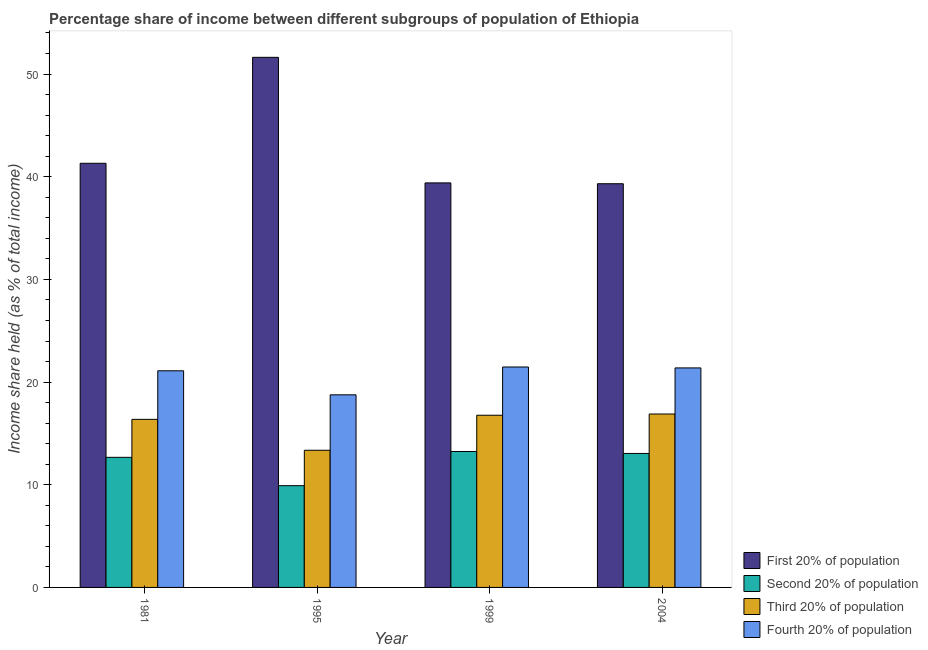How many different coloured bars are there?
Your answer should be very brief. 4. Are the number of bars per tick equal to the number of legend labels?
Your answer should be very brief. Yes. How many bars are there on the 3rd tick from the left?
Make the answer very short. 4. In how many cases, is the number of bars for a given year not equal to the number of legend labels?
Keep it short and to the point. 0. What is the share of the income held by fourth 20% of the population in 1995?
Give a very brief answer. 18.76. Across all years, what is the maximum share of the income held by fourth 20% of the population?
Provide a short and direct response. 21.47. Across all years, what is the minimum share of the income held by first 20% of the population?
Ensure brevity in your answer.  39.32. In which year was the share of the income held by first 20% of the population maximum?
Give a very brief answer. 1995. What is the total share of the income held by fourth 20% of the population in the graph?
Make the answer very short. 82.71. What is the difference between the share of the income held by third 20% of the population in 1981 and that in 2004?
Your answer should be very brief. -0.52. What is the difference between the share of the income held by fourth 20% of the population in 2004 and the share of the income held by third 20% of the population in 1981?
Provide a short and direct response. 0.28. What is the average share of the income held by second 20% of the population per year?
Provide a succinct answer. 12.22. In the year 2004, what is the difference between the share of the income held by second 20% of the population and share of the income held by fourth 20% of the population?
Your answer should be compact. 0. What is the ratio of the share of the income held by fourth 20% of the population in 1981 to that in 1999?
Your answer should be compact. 0.98. Is the share of the income held by second 20% of the population in 1999 less than that in 2004?
Your response must be concise. No. Is the difference between the share of the income held by second 20% of the population in 1981 and 1995 greater than the difference between the share of the income held by fourth 20% of the population in 1981 and 1995?
Provide a succinct answer. No. What is the difference between the highest and the second highest share of the income held by first 20% of the population?
Your response must be concise. 10.32. What is the difference between the highest and the lowest share of the income held by third 20% of the population?
Provide a succinct answer. 3.53. In how many years, is the share of the income held by first 20% of the population greater than the average share of the income held by first 20% of the population taken over all years?
Ensure brevity in your answer.  1. Is the sum of the share of the income held by first 20% of the population in 1981 and 1999 greater than the maximum share of the income held by third 20% of the population across all years?
Your response must be concise. Yes. Is it the case that in every year, the sum of the share of the income held by third 20% of the population and share of the income held by fourth 20% of the population is greater than the sum of share of the income held by second 20% of the population and share of the income held by first 20% of the population?
Keep it short and to the point. Yes. What does the 3rd bar from the left in 1999 represents?
Offer a very short reply. Third 20% of population. What does the 2nd bar from the right in 1981 represents?
Your answer should be compact. Third 20% of population. Is it the case that in every year, the sum of the share of the income held by first 20% of the population and share of the income held by second 20% of the population is greater than the share of the income held by third 20% of the population?
Offer a terse response. Yes. Are all the bars in the graph horizontal?
Give a very brief answer. No. Are the values on the major ticks of Y-axis written in scientific E-notation?
Your answer should be compact. No. Does the graph contain any zero values?
Your answer should be very brief. No. Where does the legend appear in the graph?
Ensure brevity in your answer.  Bottom right. How are the legend labels stacked?
Offer a terse response. Vertical. What is the title of the graph?
Your answer should be very brief. Percentage share of income between different subgroups of population of Ethiopia. What is the label or title of the Y-axis?
Provide a short and direct response. Income share held (as % of total income). What is the Income share held (as % of total income) of First 20% of population in 1981?
Provide a succinct answer. 41.31. What is the Income share held (as % of total income) in Second 20% of population in 1981?
Give a very brief answer. 12.67. What is the Income share held (as % of total income) in Third 20% of population in 1981?
Your answer should be compact. 16.37. What is the Income share held (as % of total income) of Fourth 20% of population in 1981?
Provide a short and direct response. 21.1. What is the Income share held (as % of total income) in First 20% of population in 1995?
Offer a terse response. 51.63. What is the Income share held (as % of total income) of Second 20% of population in 1995?
Provide a short and direct response. 9.91. What is the Income share held (as % of total income) of Third 20% of population in 1995?
Make the answer very short. 13.36. What is the Income share held (as % of total income) of Fourth 20% of population in 1995?
Offer a terse response. 18.76. What is the Income share held (as % of total income) of First 20% of population in 1999?
Ensure brevity in your answer.  39.4. What is the Income share held (as % of total income) of Second 20% of population in 1999?
Offer a very short reply. 13.24. What is the Income share held (as % of total income) of Third 20% of population in 1999?
Offer a terse response. 16.77. What is the Income share held (as % of total income) in Fourth 20% of population in 1999?
Ensure brevity in your answer.  21.47. What is the Income share held (as % of total income) in First 20% of population in 2004?
Your response must be concise. 39.32. What is the Income share held (as % of total income) of Second 20% of population in 2004?
Offer a very short reply. 13.05. What is the Income share held (as % of total income) in Third 20% of population in 2004?
Ensure brevity in your answer.  16.89. What is the Income share held (as % of total income) of Fourth 20% of population in 2004?
Your response must be concise. 21.38. Across all years, what is the maximum Income share held (as % of total income) in First 20% of population?
Provide a succinct answer. 51.63. Across all years, what is the maximum Income share held (as % of total income) of Second 20% of population?
Provide a succinct answer. 13.24. Across all years, what is the maximum Income share held (as % of total income) of Third 20% of population?
Keep it short and to the point. 16.89. Across all years, what is the maximum Income share held (as % of total income) in Fourth 20% of population?
Provide a short and direct response. 21.47. Across all years, what is the minimum Income share held (as % of total income) of First 20% of population?
Provide a succinct answer. 39.32. Across all years, what is the minimum Income share held (as % of total income) in Second 20% of population?
Your answer should be very brief. 9.91. Across all years, what is the minimum Income share held (as % of total income) in Third 20% of population?
Your response must be concise. 13.36. Across all years, what is the minimum Income share held (as % of total income) in Fourth 20% of population?
Your answer should be very brief. 18.76. What is the total Income share held (as % of total income) of First 20% of population in the graph?
Your answer should be very brief. 171.66. What is the total Income share held (as % of total income) in Second 20% of population in the graph?
Offer a very short reply. 48.87. What is the total Income share held (as % of total income) in Third 20% of population in the graph?
Keep it short and to the point. 63.39. What is the total Income share held (as % of total income) of Fourth 20% of population in the graph?
Your answer should be compact. 82.71. What is the difference between the Income share held (as % of total income) of First 20% of population in 1981 and that in 1995?
Keep it short and to the point. -10.32. What is the difference between the Income share held (as % of total income) of Second 20% of population in 1981 and that in 1995?
Make the answer very short. 2.76. What is the difference between the Income share held (as % of total income) in Third 20% of population in 1981 and that in 1995?
Provide a succinct answer. 3.01. What is the difference between the Income share held (as % of total income) of Fourth 20% of population in 1981 and that in 1995?
Ensure brevity in your answer.  2.34. What is the difference between the Income share held (as % of total income) in First 20% of population in 1981 and that in 1999?
Ensure brevity in your answer.  1.91. What is the difference between the Income share held (as % of total income) of Second 20% of population in 1981 and that in 1999?
Provide a succinct answer. -0.57. What is the difference between the Income share held (as % of total income) in Fourth 20% of population in 1981 and that in 1999?
Your response must be concise. -0.37. What is the difference between the Income share held (as % of total income) in First 20% of population in 1981 and that in 2004?
Offer a very short reply. 1.99. What is the difference between the Income share held (as % of total income) of Second 20% of population in 1981 and that in 2004?
Your response must be concise. -0.38. What is the difference between the Income share held (as % of total income) of Third 20% of population in 1981 and that in 2004?
Offer a terse response. -0.52. What is the difference between the Income share held (as % of total income) in Fourth 20% of population in 1981 and that in 2004?
Provide a succinct answer. -0.28. What is the difference between the Income share held (as % of total income) in First 20% of population in 1995 and that in 1999?
Give a very brief answer. 12.23. What is the difference between the Income share held (as % of total income) of Second 20% of population in 1995 and that in 1999?
Provide a short and direct response. -3.33. What is the difference between the Income share held (as % of total income) of Third 20% of population in 1995 and that in 1999?
Your answer should be compact. -3.41. What is the difference between the Income share held (as % of total income) in Fourth 20% of population in 1995 and that in 1999?
Give a very brief answer. -2.71. What is the difference between the Income share held (as % of total income) of First 20% of population in 1995 and that in 2004?
Offer a terse response. 12.31. What is the difference between the Income share held (as % of total income) of Second 20% of population in 1995 and that in 2004?
Provide a short and direct response. -3.14. What is the difference between the Income share held (as % of total income) of Third 20% of population in 1995 and that in 2004?
Offer a terse response. -3.53. What is the difference between the Income share held (as % of total income) in Fourth 20% of population in 1995 and that in 2004?
Provide a succinct answer. -2.62. What is the difference between the Income share held (as % of total income) in First 20% of population in 1999 and that in 2004?
Provide a short and direct response. 0.08. What is the difference between the Income share held (as % of total income) of Second 20% of population in 1999 and that in 2004?
Make the answer very short. 0.19. What is the difference between the Income share held (as % of total income) in Third 20% of population in 1999 and that in 2004?
Offer a very short reply. -0.12. What is the difference between the Income share held (as % of total income) of Fourth 20% of population in 1999 and that in 2004?
Make the answer very short. 0.09. What is the difference between the Income share held (as % of total income) in First 20% of population in 1981 and the Income share held (as % of total income) in Second 20% of population in 1995?
Your answer should be compact. 31.4. What is the difference between the Income share held (as % of total income) of First 20% of population in 1981 and the Income share held (as % of total income) of Third 20% of population in 1995?
Your answer should be compact. 27.95. What is the difference between the Income share held (as % of total income) of First 20% of population in 1981 and the Income share held (as % of total income) of Fourth 20% of population in 1995?
Give a very brief answer. 22.55. What is the difference between the Income share held (as % of total income) in Second 20% of population in 1981 and the Income share held (as % of total income) in Third 20% of population in 1995?
Offer a very short reply. -0.69. What is the difference between the Income share held (as % of total income) in Second 20% of population in 1981 and the Income share held (as % of total income) in Fourth 20% of population in 1995?
Your answer should be very brief. -6.09. What is the difference between the Income share held (as % of total income) in Third 20% of population in 1981 and the Income share held (as % of total income) in Fourth 20% of population in 1995?
Ensure brevity in your answer.  -2.39. What is the difference between the Income share held (as % of total income) of First 20% of population in 1981 and the Income share held (as % of total income) of Second 20% of population in 1999?
Your answer should be very brief. 28.07. What is the difference between the Income share held (as % of total income) of First 20% of population in 1981 and the Income share held (as % of total income) of Third 20% of population in 1999?
Your response must be concise. 24.54. What is the difference between the Income share held (as % of total income) of First 20% of population in 1981 and the Income share held (as % of total income) of Fourth 20% of population in 1999?
Provide a short and direct response. 19.84. What is the difference between the Income share held (as % of total income) in Second 20% of population in 1981 and the Income share held (as % of total income) in Fourth 20% of population in 1999?
Make the answer very short. -8.8. What is the difference between the Income share held (as % of total income) in First 20% of population in 1981 and the Income share held (as % of total income) in Second 20% of population in 2004?
Give a very brief answer. 28.26. What is the difference between the Income share held (as % of total income) in First 20% of population in 1981 and the Income share held (as % of total income) in Third 20% of population in 2004?
Make the answer very short. 24.42. What is the difference between the Income share held (as % of total income) of First 20% of population in 1981 and the Income share held (as % of total income) of Fourth 20% of population in 2004?
Your answer should be compact. 19.93. What is the difference between the Income share held (as % of total income) of Second 20% of population in 1981 and the Income share held (as % of total income) of Third 20% of population in 2004?
Provide a succinct answer. -4.22. What is the difference between the Income share held (as % of total income) in Second 20% of population in 1981 and the Income share held (as % of total income) in Fourth 20% of population in 2004?
Your response must be concise. -8.71. What is the difference between the Income share held (as % of total income) in Third 20% of population in 1981 and the Income share held (as % of total income) in Fourth 20% of population in 2004?
Give a very brief answer. -5.01. What is the difference between the Income share held (as % of total income) of First 20% of population in 1995 and the Income share held (as % of total income) of Second 20% of population in 1999?
Your response must be concise. 38.39. What is the difference between the Income share held (as % of total income) of First 20% of population in 1995 and the Income share held (as % of total income) of Third 20% of population in 1999?
Ensure brevity in your answer.  34.86. What is the difference between the Income share held (as % of total income) in First 20% of population in 1995 and the Income share held (as % of total income) in Fourth 20% of population in 1999?
Provide a succinct answer. 30.16. What is the difference between the Income share held (as % of total income) in Second 20% of population in 1995 and the Income share held (as % of total income) in Third 20% of population in 1999?
Give a very brief answer. -6.86. What is the difference between the Income share held (as % of total income) in Second 20% of population in 1995 and the Income share held (as % of total income) in Fourth 20% of population in 1999?
Give a very brief answer. -11.56. What is the difference between the Income share held (as % of total income) of Third 20% of population in 1995 and the Income share held (as % of total income) of Fourth 20% of population in 1999?
Provide a succinct answer. -8.11. What is the difference between the Income share held (as % of total income) of First 20% of population in 1995 and the Income share held (as % of total income) of Second 20% of population in 2004?
Give a very brief answer. 38.58. What is the difference between the Income share held (as % of total income) in First 20% of population in 1995 and the Income share held (as % of total income) in Third 20% of population in 2004?
Offer a very short reply. 34.74. What is the difference between the Income share held (as % of total income) of First 20% of population in 1995 and the Income share held (as % of total income) of Fourth 20% of population in 2004?
Make the answer very short. 30.25. What is the difference between the Income share held (as % of total income) in Second 20% of population in 1995 and the Income share held (as % of total income) in Third 20% of population in 2004?
Provide a succinct answer. -6.98. What is the difference between the Income share held (as % of total income) of Second 20% of population in 1995 and the Income share held (as % of total income) of Fourth 20% of population in 2004?
Your answer should be very brief. -11.47. What is the difference between the Income share held (as % of total income) in Third 20% of population in 1995 and the Income share held (as % of total income) in Fourth 20% of population in 2004?
Your answer should be very brief. -8.02. What is the difference between the Income share held (as % of total income) of First 20% of population in 1999 and the Income share held (as % of total income) of Second 20% of population in 2004?
Your answer should be compact. 26.35. What is the difference between the Income share held (as % of total income) of First 20% of population in 1999 and the Income share held (as % of total income) of Third 20% of population in 2004?
Give a very brief answer. 22.51. What is the difference between the Income share held (as % of total income) of First 20% of population in 1999 and the Income share held (as % of total income) of Fourth 20% of population in 2004?
Provide a short and direct response. 18.02. What is the difference between the Income share held (as % of total income) of Second 20% of population in 1999 and the Income share held (as % of total income) of Third 20% of population in 2004?
Give a very brief answer. -3.65. What is the difference between the Income share held (as % of total income) in Second 20% of population in 1999 and the Income share held (as % of total income) in Fourth 20% of population in 2004?
Your answer should be compact. -8.14. What is the difference between the Income share held (as % of total income) in Third 20% of population in 1999 and the Income share held (as % of total income) in Fourth 20% of population in 2004?
Your answer should be very brief. -4.61. What is the average Income share held (as % of total income) in First 20% of population per year?
Make the answer very short. 42.91. What is the average Income share held (as % of total income) in Second 20% of population per year?
Your answer should be very brief. 12.22. What is the average Income share held (as % of total income) in Third 20% of population per year?
Give a very brief answer. 15.85. What is the average Income share held (as % of total income) of Fourth 20% of population per year?
Keep it short and to the point. 20.68. In the year 1981, what is the difference between the Income share held (as % of total income) in First 20% of population and Income share held (as % of total income) in Second 20% of population?
Keep it short and to the point. 28.64. In the year 1981, what is the difference between the Income share held (as % of total income) in First 20% of population and Income share held (as % of total income) in Third 20% of population?
Provide a succinct answer. 24.94. In the year 1981, what is the difference between the Income share held (as % of total income) of First 20% of population and Income share held (as % of total income) of Fourth 20% of population?
Provide a succinct answer. 20.21. In the year 1981, what is the difference between the Income share held (as % of total income) of Second 20% of population and Income share held (as % of total income) of Third 20% of population?
Provide a short and direct response. -3.7. In the year 1981, what is the difference between the Income share held (as % of total income) of Second 20% of population and Income share held (as % of total income) of Fourth 20% of population?
Offer a very short reply. -8.43. In the year 1981, what is the difference between the Income share held (as % of total income) in Third 20% of population and Income share held (as % of total income) in Fourth 20% of population?
Give a very brief answer. -4.73. In the year 1995, what is the difference between the Income share held (as % of total income) of First 20% of population and Income share held (as % of total income) of Second 20% of population?
Your response must be concise. 41.72. In the year 1995, what is the difference between the Income share held (as % of total income) of First 20% of population and Income share held (as % of total income) of Third 20% of population?
Ensure brevity in your answer.  38.27. In the year 1995, what is the difference between the Income share held (as % of total income) of First 20% of population and Income share held (as % of total income) of Fourth 20% of population?
Offer a very short reply. 32.87. In the year 1995, what is the difference between the Income share held (as % of total income) in Second 20% of population and Income share held (as % of total income) in Third 20% of population?
Ensure brevity in your answer.  -3.45. In the year 1995, what is the difference between the Income share held (as % of total income) in Second 20% of population and Income share held (as % of total income) in Fourth 20% of population?
Provide a short and direct response. -8.85. In the year 1995, what is the difference between the Income share held (as % of total income) of Third 20% of population and Income share held (as % of total income) of Fourth 20% of population?
Your answer should be compact. -5.4. In the year 1999, what is the difference between the Income share held (as % of total income) of First 20% of population and Income share held (as % of total income) of Second 20% of population?
Provide a short and direct response. 26.16. In the year 1999, what is the difference between the Income share held (as % of total income) in First 20% of population and Income share held (as % of total income) in Third 20% of population?
Offer a terse response. 22.63. In the year 1999, what is the difference between the Income share held (as % of total income) in First 20% of population and Income share held (as % of total income) in Fourth 20% of population?
Your response must be concise. 17.93. In the year 1999, what is the difference between the Income share held (as % of total income) of Second 20% of population and Income share held (as % of total income) of Third 20% of population?
Make the answer very short. -3.53. In the year 1999, what is the difference between the Income share held (as % of total income) in Second 20% of population and Income share held (as % of total income) in Fourth 20% of population?
Offer a terse response. -8.23. In the year 2004, what is the difference between the Income share held (as % of total income) of First 20% of population and Income share held (as % of total income) of Second 20% of population?
Ensure brevity in your answer.  26.27. In the year 2004, what is the difference between the Income share held (as % of total income) in First 20% of population and Income share held (as % of total income) in Third 20% of population?
Your answer should be compact. 22.43. In the year 2004, what is the difference between the Income share held (as % of total income) in First 20% of population and Income share held (as % of total income) in Fourth 20% of population?
Give a very brief answer. 17.94. In the year 2004, what is the difference between the Income share held (as % of total income) in Second 20% of population and Income share held (as % of total income) in Third 20% of population?
Ensure brevity in your answer.  -3.84. In the year 2004, what is the difference between the Income share held (as % of total income) in Second 20% of population and Income share held (as % of total income) in Fourth 20% of population?
Provide a short and direct response. -8.33. In the year 2004, what is the difference between the Income share held (as % of total income) in Third 20% of population and Income share held (as % of total income) in Fourth 20% of population?
Offer a terse response. -4.49. What is the ratio of the Income share held (as % of total income) of First 20% of population in 1981 to that in 1995?
Your response must be concise. 0.8. What is the ratio of the Income share held (as % of total income) in Second 20% of population in 1981 to that in 1995?
Give a very brief answer. 1.28. What is the ratio of the Income share held (as % of total income) of Third 20% of population in 1981 to that in 1995?
Offer a very short reply. 1.23. What is the ratio of the Income share held (as % of total income) in Fourth 20% of population in 1981 to that in 1995?
Provide a short and direct response. 1.12. What is the ratio of the Income share held (as % of total income) in First 20% of population in 1981 to that in 1999?
Provide a short and direct response. 1.05. What is the ratio of the Income share held (as % of total income) in Second 20% of population in 1981 to that in 1999?
Your answer should be compact. 0.96. What is the ratio of the Income share held (as % of total income) of Third 20% of population in 1981 to that in 1999?
Make the answer very short. 0.98. What is the ratio of the Income share held (as % of total income) in Fourth 20% of population in 1981 to that in 1999?
Your answer should be very brief. 0.98. What is the ratio of the Income share held (as % of total income) in First 20% of population in 1981 to that in 2004?
Give a very brief answer. 1.05. What is the ratio of the Income share held (as % of total income) of Second 20% of population in 1981 to that in 2004?
Your answer should be compact. 0.97. What is the ratio of the Income share held (as % of total income) of Third 20% of population in 1981 to that in 2004?
Offer a very short reply. 0.97. What is the ratio of the Income share held (as % of total income) in Fourth 20% of population in 1981 to that in 2004?
Ensure brevity in your answer.  0.99. What is the ratio of the Income share held (as % of total income) of First 20% of population in 1995 to that in 1999?
Offer a terse response. 1.31. What is the ratio of the Income share held (as % of total income) of Second 20% of population in 1995 to that in 1999?
Offer a terse response. 0.75. What is the ratio of the Income share held (as % of total income) of Third 20% of population in 1995 to that in 1999?
Offer a terse response. 0.8. What is the ratio of the Income share held (as % of total income) in Fourth 20% of population in 1995 to that in 1999?
Offer a terse response. 0.87. What is the ratio of the Income share held (as % of total income) in First 20% of population in 1995 to that in 2004?
Your response must be concise. 1.31. What is the ratio of the Income share held (as % of total income) of Second 20% of population in 1995 to that in 2004?
Your response must be concise. 0.76. What is the ratio of the Income share held (as % of total income) of Third 20% of population in 1995 to that in 2004?
Your answer should be compact. 0.79. What is the ratio of the Income share held (as % of total income) of Fourth 20% of population in 1995 to that in 2004?
Give a very brief answer. 0.88. What is the ratio of the Income share held (as % of total income) in Second 20% of population in 1999 to that in 2004?
Your answer should be compact. 1.01. What is the ratio of the Income share held (as % of total income) of Fourth 20% of population in 1999 to that in 2004?
Your response must be concise. 1. What is the difference between the highest and the second highest Income share held (as % of total income) in First 20% of population?
Offer a very short reply. 10.32. What is the difference between the highest and the second highest Income share held (as % of total income) of Second 20% of population?
Give a very brief answer. 0.19. What is the difference between the highest and the second highest Income share held (as % of total income) of Third 20% of population?
Offer a very short reply. 0.12. What is the difference between the highest and the second highest Income share held (as % of total income) of Fourth 20% of population?
Offer a terse response. 0.09. What is the difference between the highest and the lowest Income share held (as % of total income) in First 20% of population?
Provide a short and direct response. 12.31. What is the difference between the highest and the lowest Income share held (as % of total income) in Second 20% of population?
Your response must be concise. 3.33. What is the difference between the highest and the lowest Income share held (as % of total income) in Third 20% of population?
Give a very brief answer. 3.53. What is the difference between the highest and the lowest Income share held (as % of total income) of Fourth 20% of population?
Your answer should be very brief. 2.71. 